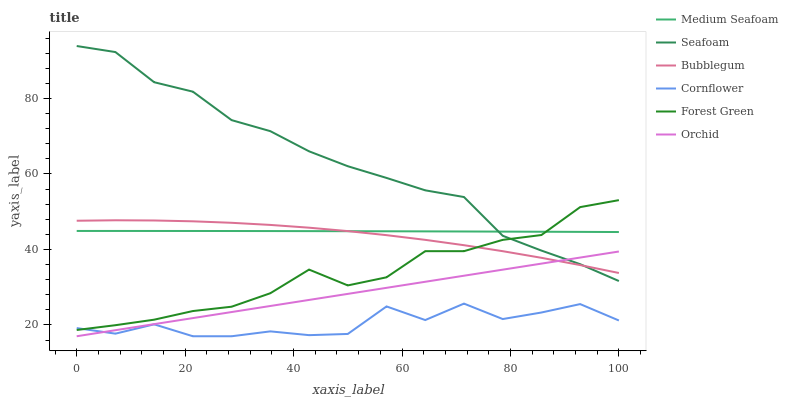Does Cornflower have the minimum area under the curve?
Answer yes or no. Yes. Does Seafoam have the maximum area under the curve?
Answer yes or no. Yes. Does Bubblegum have the minimum area under the curve?
Answer yes or no. No. Does Bubblegum have the maximum area under the curve?
Answer yes or no. No. Is Orchid the smoothest?
Answer yes or no. Yes. Is Cornflower the roughest?
Answer yes or no. Yes. Is Seafoam the smoothest?
Answer yes or no. No. Is Seafoam the roughest?
Answer yes or no. No. Does Cornflower have the lowest value?
Answer yes or no. Yes. Does Seafoam have the lowest value?
Answer yes or no. No. Does Seafoam have the highest value?
Answer yes or no. Yes. Does Bubblegum have the highest value?
Answer yes or no. No. Is Cornflower less than Medium Seafoam?
Answer yes or no. Yes. Is Bubblegum greater than Cornflower?
Answer yes or no. Yes. Does Seafoam intersect Forest Green?
Answer yes or no. Yes. Is Seafoam less than Forest Green?
Answer yes or no. No. Is Seafoam greater than Forest Green?
Answer yes or no. No. Does Cornflower intersect Medium Seafoam?
Answer yes or no. No. 